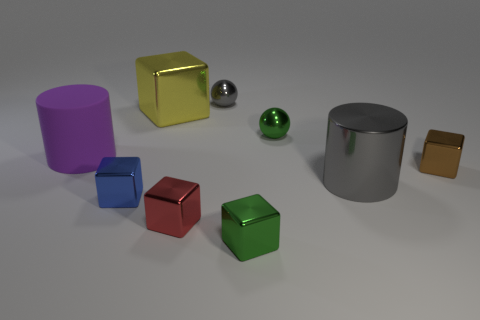What material is the thing that is the same color as the metal cylinder?
Make the answer very short. Metal. Are there any spheres that have the same color as the metallic cylinder?
Offer a very short reply. Yes. There is a small blue object that is the same shape as the big yellow object; what is it made of?
Offer a terse response. Metal. There is a cube that is behind the metallic cylinder and on the left side of the brown thing; what size is it?
Provide a succinct answer. Large. There is a tiny metal ball behind the small green sphere; is its color the same as the shiny cylinder?
Your answer should be compact. Yes. What is the size of the gray sphere?
Keep it short and to the point. Small. How many blue things are matte objects or balls?
Offer a terse response. 0. There is a cylinder that is behind the gray shiny object that is in front of the small brown thing; what is its size?
Provide a succinct answer. Large. Does the metal cylinder have the same color as the small metallic ball behind the large yellow metal object?
Ensure brevity in your answer.  Yes. How many other objects are the same material as the big gray thing?
Your response must be concise. 7. 